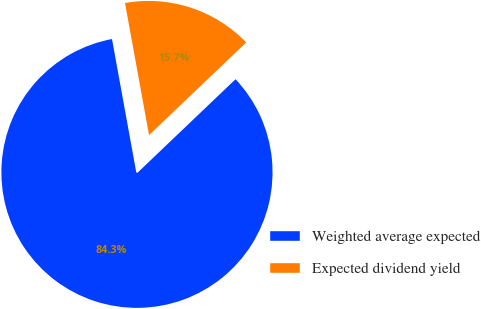<chart> <loc_0><loc_0><loc_500><loc_500><pie_chart><fcel>Weighted average expected<fcel>Expected dividend yield<nl><fcel>84.26%<fcel>15.74%<nl></chart> 